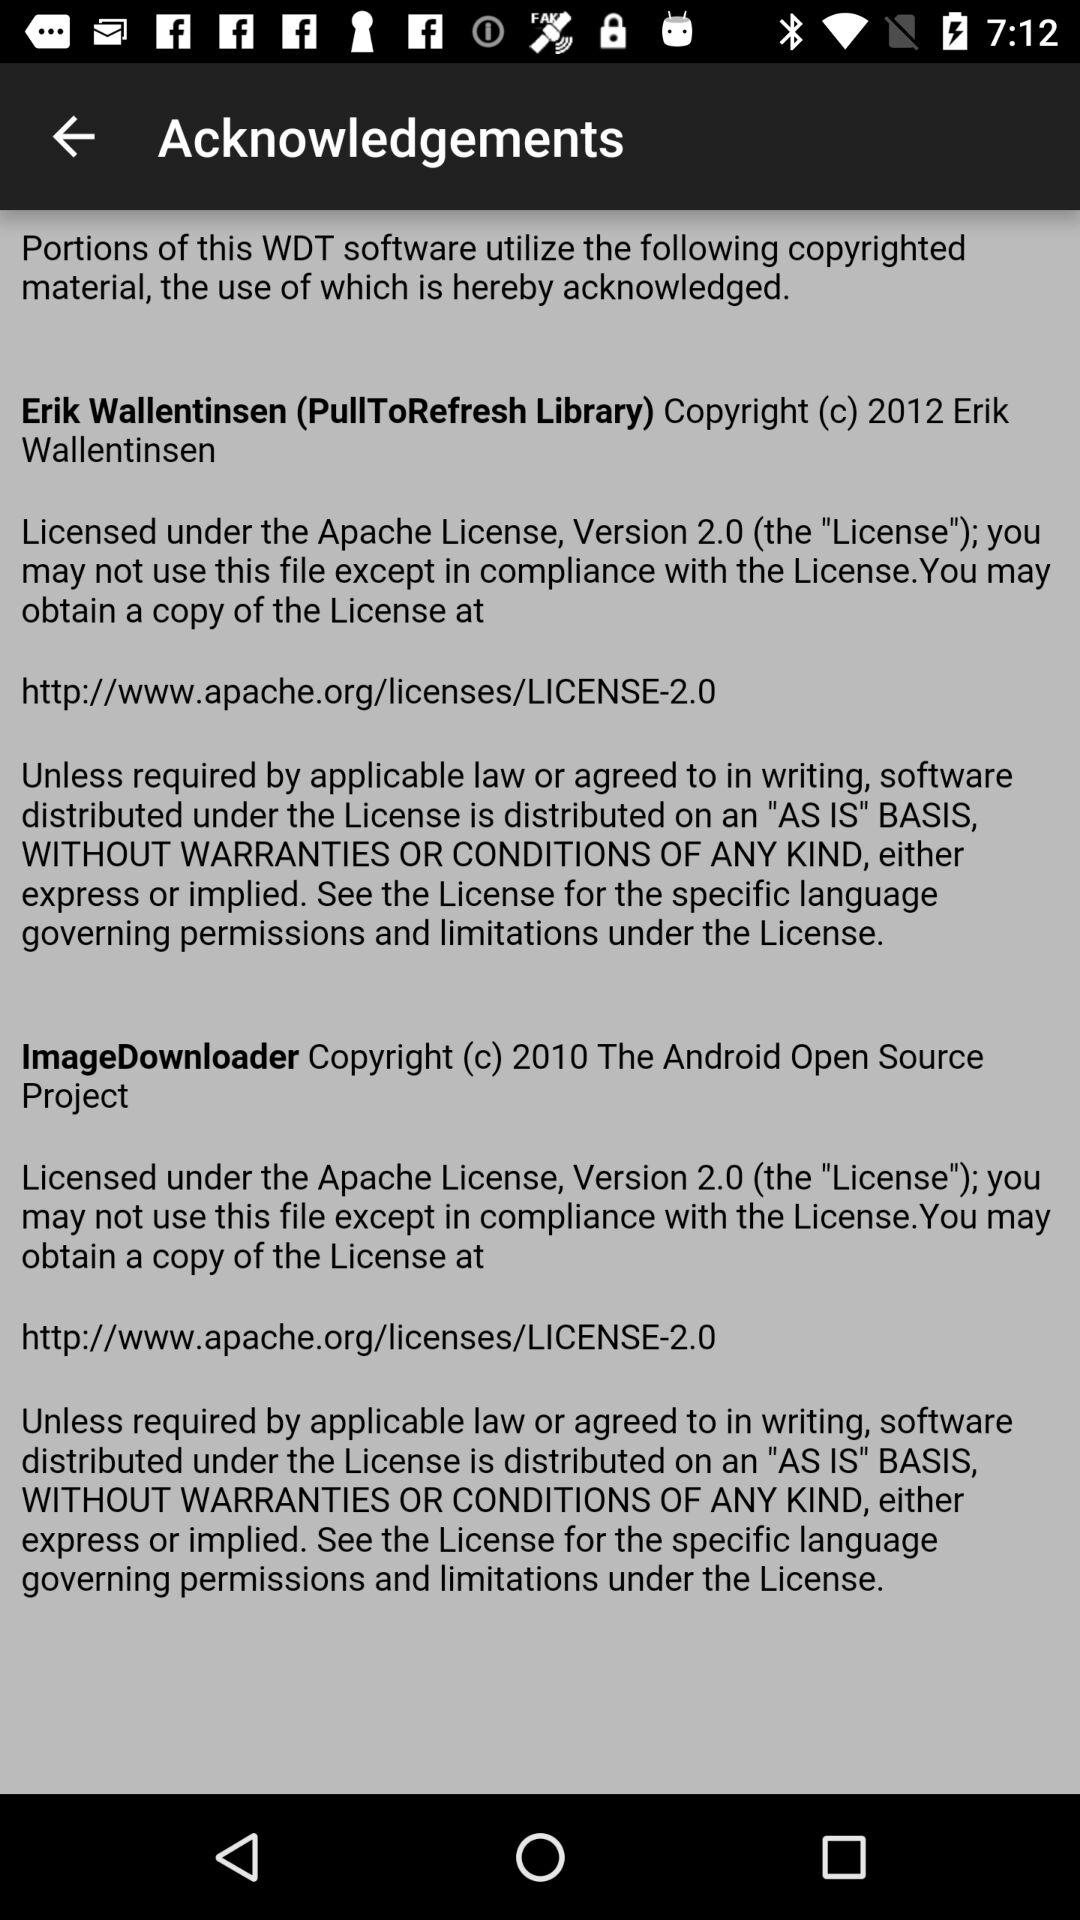What is the user's name?
When the provided information is insufficient, respond with <no answer>. <no answer> 